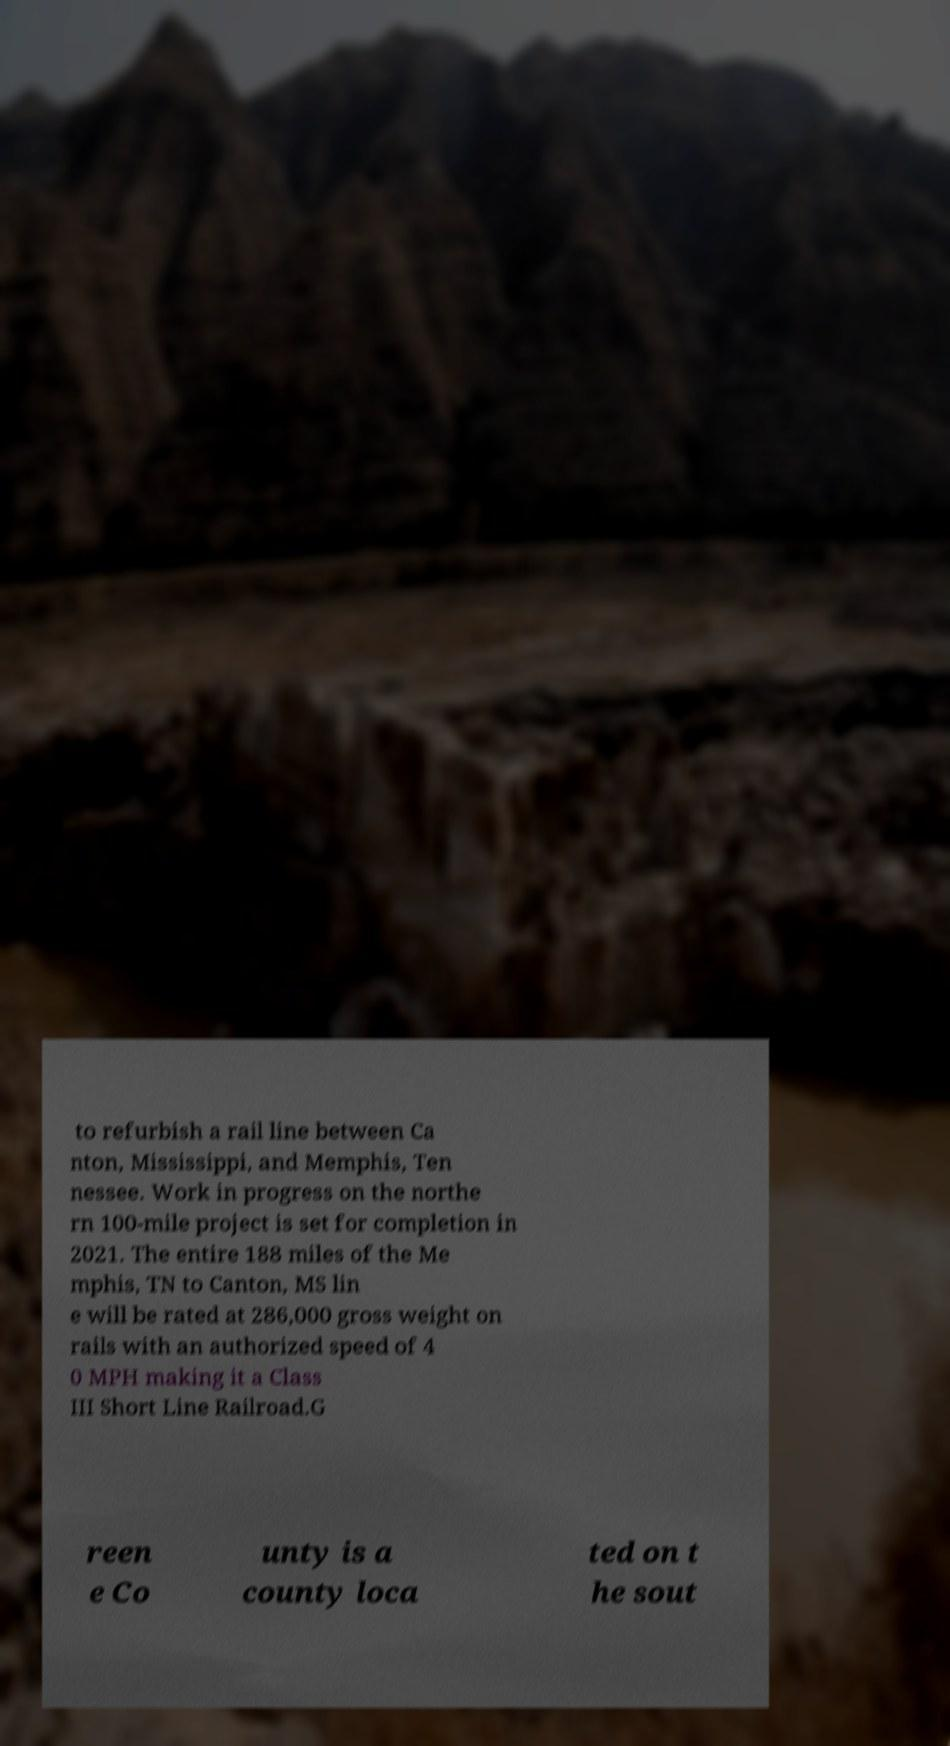Could you assist in decoding the text presented in this image and type it out clearly? to refurbish a rail line between Ca nton, Mississippi, and Memphis, Ten nessee. Work in progress on the northe rn 100-mile project is set for completion in 2021. The entire 188 miles of the Me mphis, TN to Canton, MS lin e will be rated at 286,000 gross weight on rails with an authorized speed of 4 0 MPH making it a Class III Short Line Railroad.G reen e Co unty is a county loca ted on t he sout 